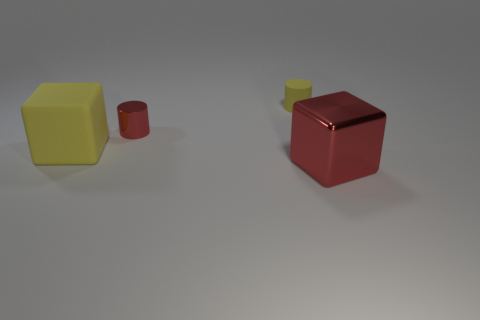Add 2 brown metal spheres. How many objects exist? 6 Subtract all tiny things. Subtract all tiny cyan matte things. How many objects are left? 2 Add 2 small yellow objects. How many small yellow objects are left? 3 Add 1 large gray rubber blocks. How many large gray rubber blocks exist? 1 Subtract 0 yellow balls. How many objects are left? 4 